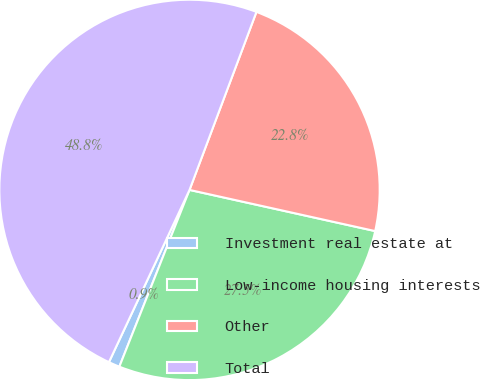Convert chart to OTSL. <chart><loc_0><loc_0><loc_500><loc_500><pie_chart><fcel>Investment real estate at<fcel>Low-income housing interests<fcel>Other<fcel>Total<nl><fcel>0.95%<fcel>27.54%<fcel>22.75%<fcel>48.76%<nl></chart> 